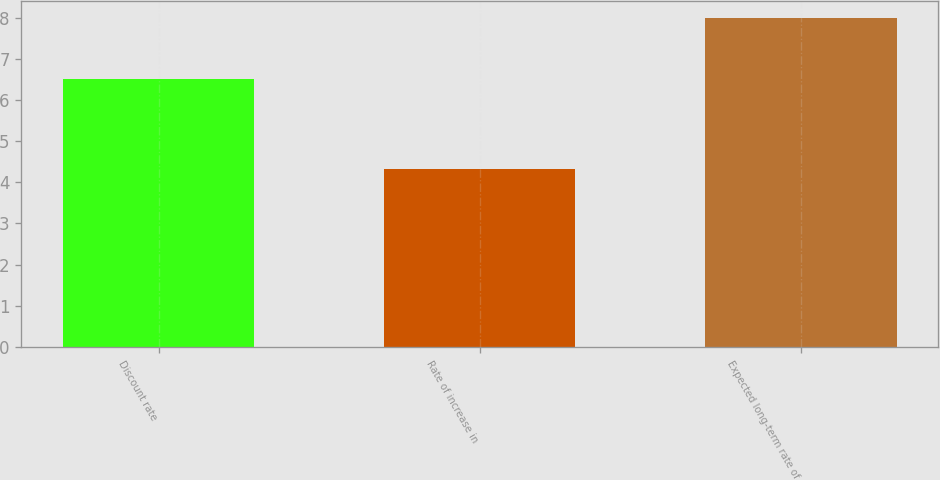Convert chart. <chart><loc_0><loc_0><loc_500><loc_500><bar_chart><fcel>Discount rate<fcel>Rate of increase in<fcel>Expected long-term rate of<nl><fcel>6.5<fcel>4.33<fcel>8<nl></chart> 